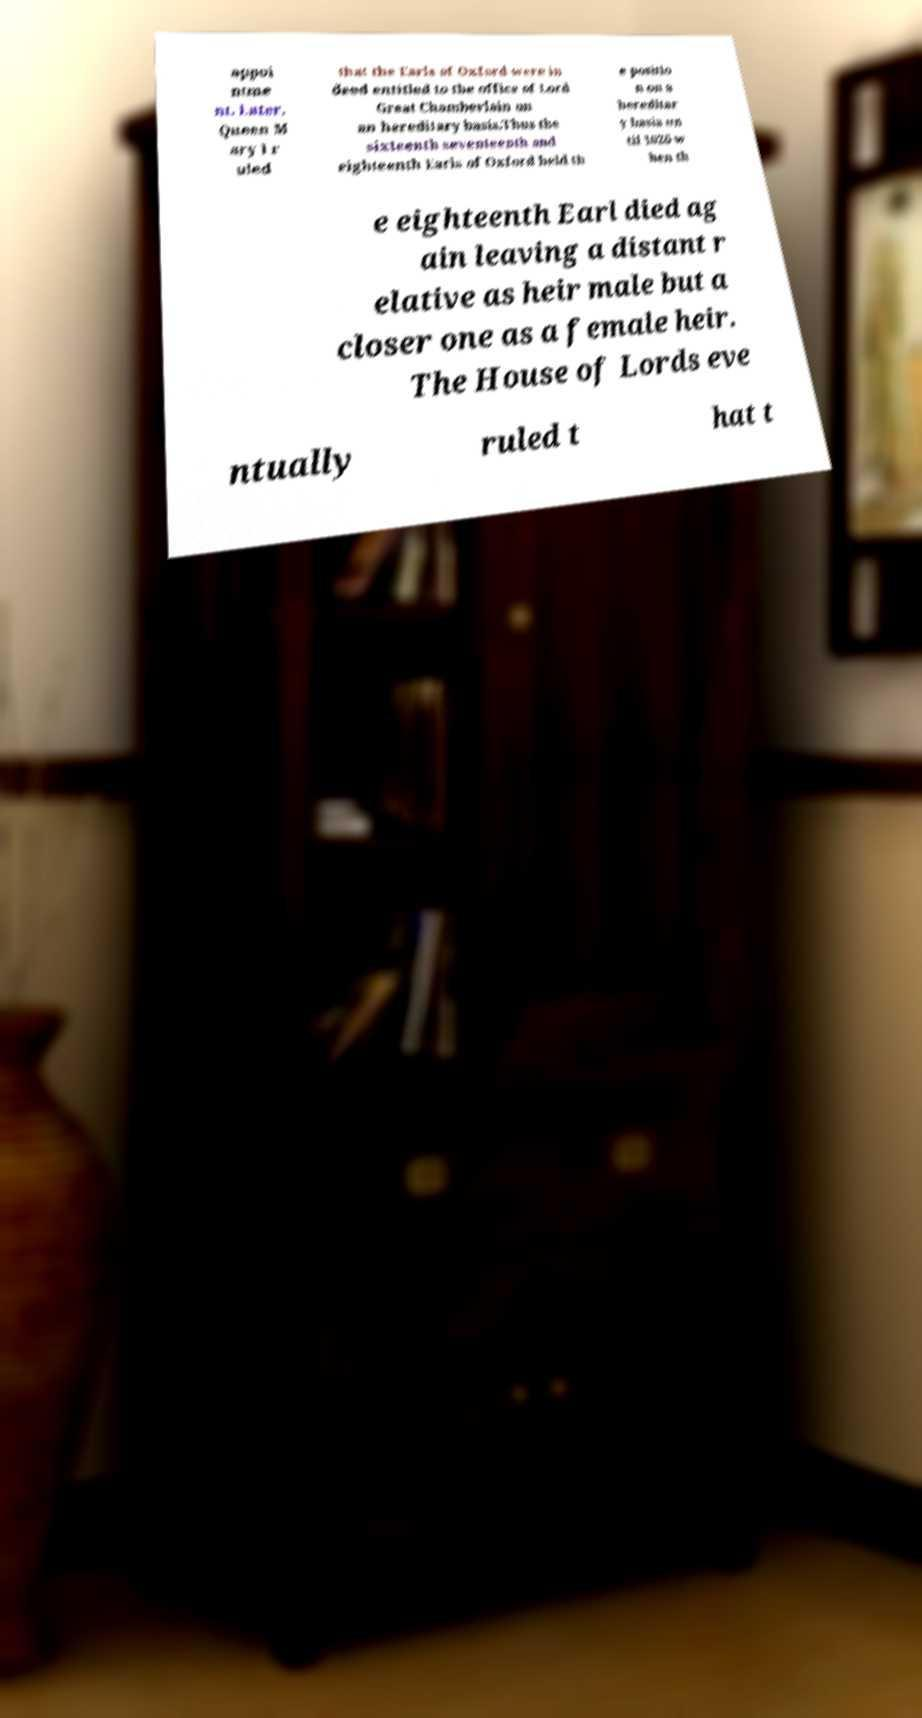Could you assist in decoding the text presented in this image and type it out clearly? appoi ntme nt. Later, Queen M ary I r uled that the Earls of Oxford were in deed entitled to the office of Lord Great Chamberlain on an hereditary basis.Thus the sixteenth seventeenth and eighteenth Earls of Oxford held th e positio n on a hereditar y basis un til 1626 w hen th e eighteenth Earl died ag ain leaving a distant r elative as heir male but a closer one as a female heir. The House of Lords eve ntually ruled t hat t 